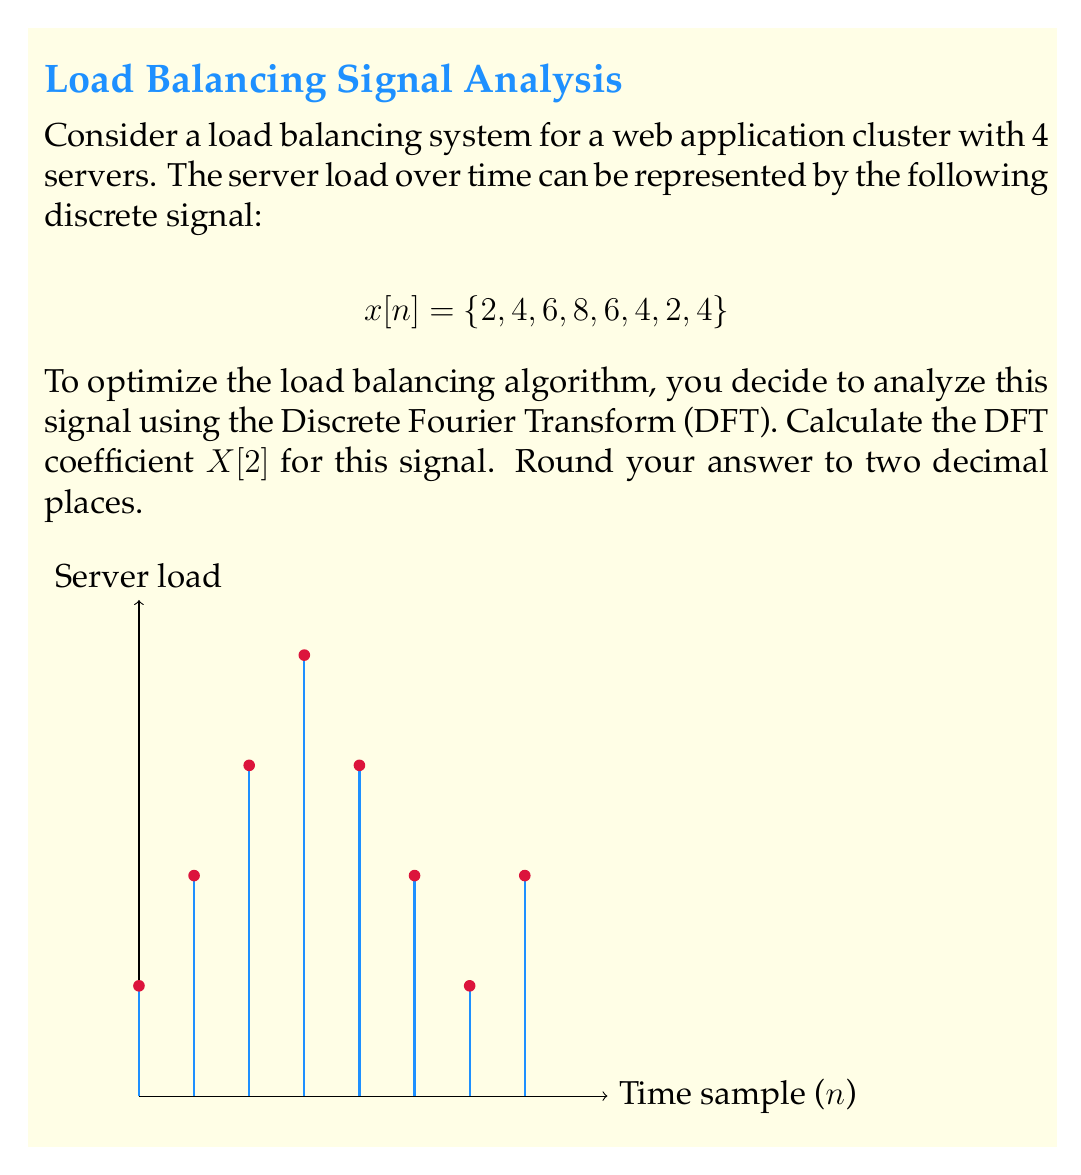Can you answer this question? To solve this problem, we'll follow these steps:

1) The DFT formula for X[k] is:

   $$X[k] = \sum_{n=0}^{N-1} x[n] e^{-j2\pi kn/N}$$

   where N is the length of the signal (in this case, N = 8).

2) We need to calculate X[2], so k = 2:

   $$X[2] = \sum_{n=0}^{7} x[n] e^{-j2\pi (2)n/8}$$

3) Expand this sum:

   $$X[2] = 2e^{-j\pi(0)/4} + 4e^{-j\pi(2)/4} + 6e^{-j\pi(4)/4} + 8e^{-j\pi(6)/4} + 6e^{-j\pi(8)/4} + 4e^{-j\pi(10)/4} + 2e^{-j\pi(12)/4} + 4e^{-j\pi(14)/4}$$

4) Simplify the exponents:

   $$X[2] = 2 + 4e^{-j\pi/2} + 6e^{-j\pi} + 8e^{-j3\pi/2} + 6e^{-j2\pi} + 4e^{-j5\pi/2} + 2e^{-j3\pi} + 4e^{-j7\pi/2}$$

5) Recall Euler's formula: $e^{-j\theta} = \cos\theta - j\sin\theta$

6) Apply this to each term:

   $$X[2] = 2 + 4(-j) + 6(-1) + 8(j) + 6(1) + 4(-j) + 2(-1) + 4(j)$$

7) Combine real and imaginary parts:

   $$X[2] = (2 - 6 + 6 - 2) + j(8 - 4 - 4 + 4) = 0 + 4j$$

8) The magnitude of this complex number is:

   $$|X[2]| = \sqrt{0^2 + 4^2} = 4$$

Rounded to two decimal places, this is 4.00.
Answer: 4.00 